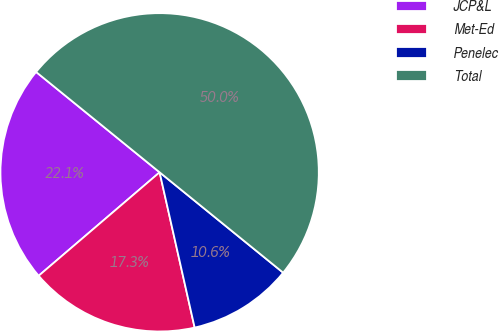<chart> <loc_0><loc_0><loc_500><loc_500><pie_chart><fcel>JCP&L<fcel>Met-Ed<fcel>Penelec<fcel>Total<nl><fcel>22.12%<fcel>17.27%<fcel>10.61%<fcel>50.0%<nl></chart> 